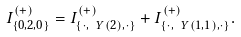Convert formula to latex. <formula><loc_0><loc_0><loc_500><loc_500>I ^ { ( + ) } _ { \{ 0 , 2 , 0 \} } = I ^ { ( + ) } _ { \{ \cdot , \ Y ( 2 ) , \cdot \} } + I ^ { ( + ) } _ { \{ \cdot , \ Y ( 1 , 1 ) , \cdot \} } .</formula> 